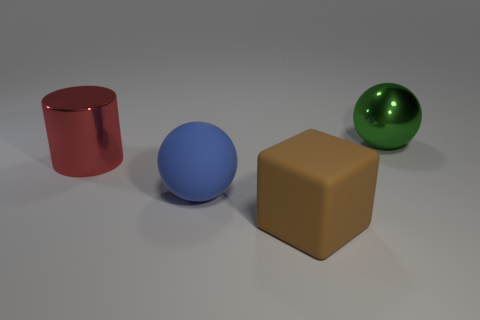Subtract all blocks. How many objects are left? 3 Add 2 green metallic objects. How many objects exist? 6 Subtract all brown balls. How many green blocks are left? 0 Add 1 green spheres. How many green spheres are left? 2 Add 3 red cylinders. How many red cylinders exist? 4 Subtract 0 blue cylinders. How many objects are left? 4 Subtract 1 cylinders. How many cylinders are left? 0 Subtract all purple cylinders. Subtract all cyan cubes. How many cylinders are left? 1 Subtract all purple shiny objects. Subtract all large matte blocks. How many objects are left? 3 